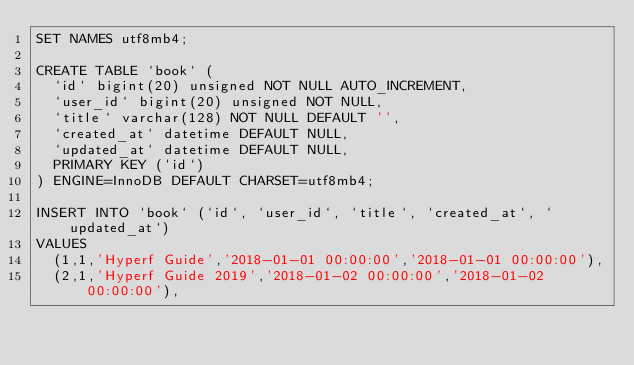Convert code to text. <code><loc_0><loc_0><loc_500><loc_500><_SQL_>SET NAMES utf8mb4;

CREATE TABLE `book` (
  `id` bigint(20) unsigned NOT NULL AUTO_INCREMENT,
  `user_id` bigint(20) unsigned NOT NULL,
  `title` varchar(128) NOT NULL DEFAULT '',
  `created_at` datetime DEFAULT NULL,
  `updated_at` datetime DEFAULT NULL,
  PRIMARY KEY (`id`)
) ENGINE=InnoDB DEFAULT CHARSET=utf8mb4;

INSERT INTO `book` (`id`, `user_id`, `title`, `created_at`, `updated_at`)
VALUES
	(1,1,'Hyperf Guide','2018-01-01 00:00:00','2018-01-01 00:00:00'),
	(2,1,'Hyperf Guide 2019','2018-01-02 00:00:00','2018-01-02 00:00:00'),</code> 